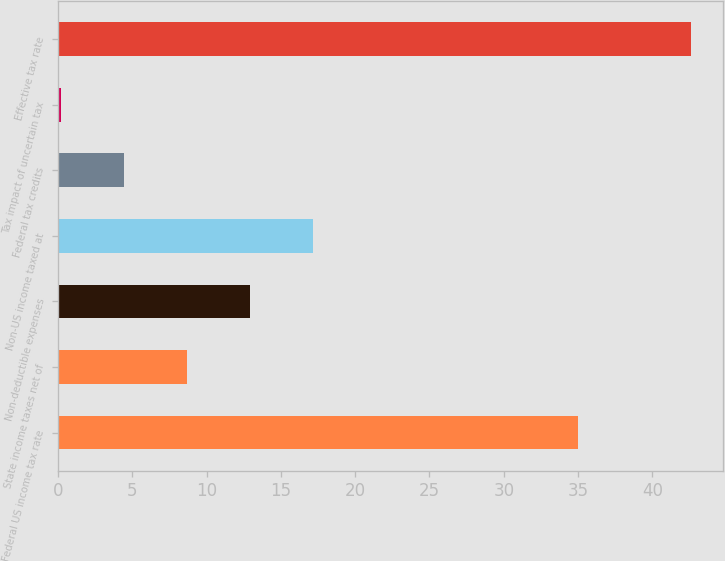<chart> <loc_0><loc_0><loc_500><loc_500><bar_chart><fcel>Federal US income tax rate<fcel>State income taxes net of<fcel>Non-deductible expenses<fcel>Non-US income taxed at<fcel>Federal tax credits<fcel>Tax impact of uncertain tax<fcel>Effective tax rate<nl><fcel>35<fcel>8.68<fcel>12.92<fcel>17.16<fcel>4.44<fcel>0.2<fcel>42.6<nl></chart> 